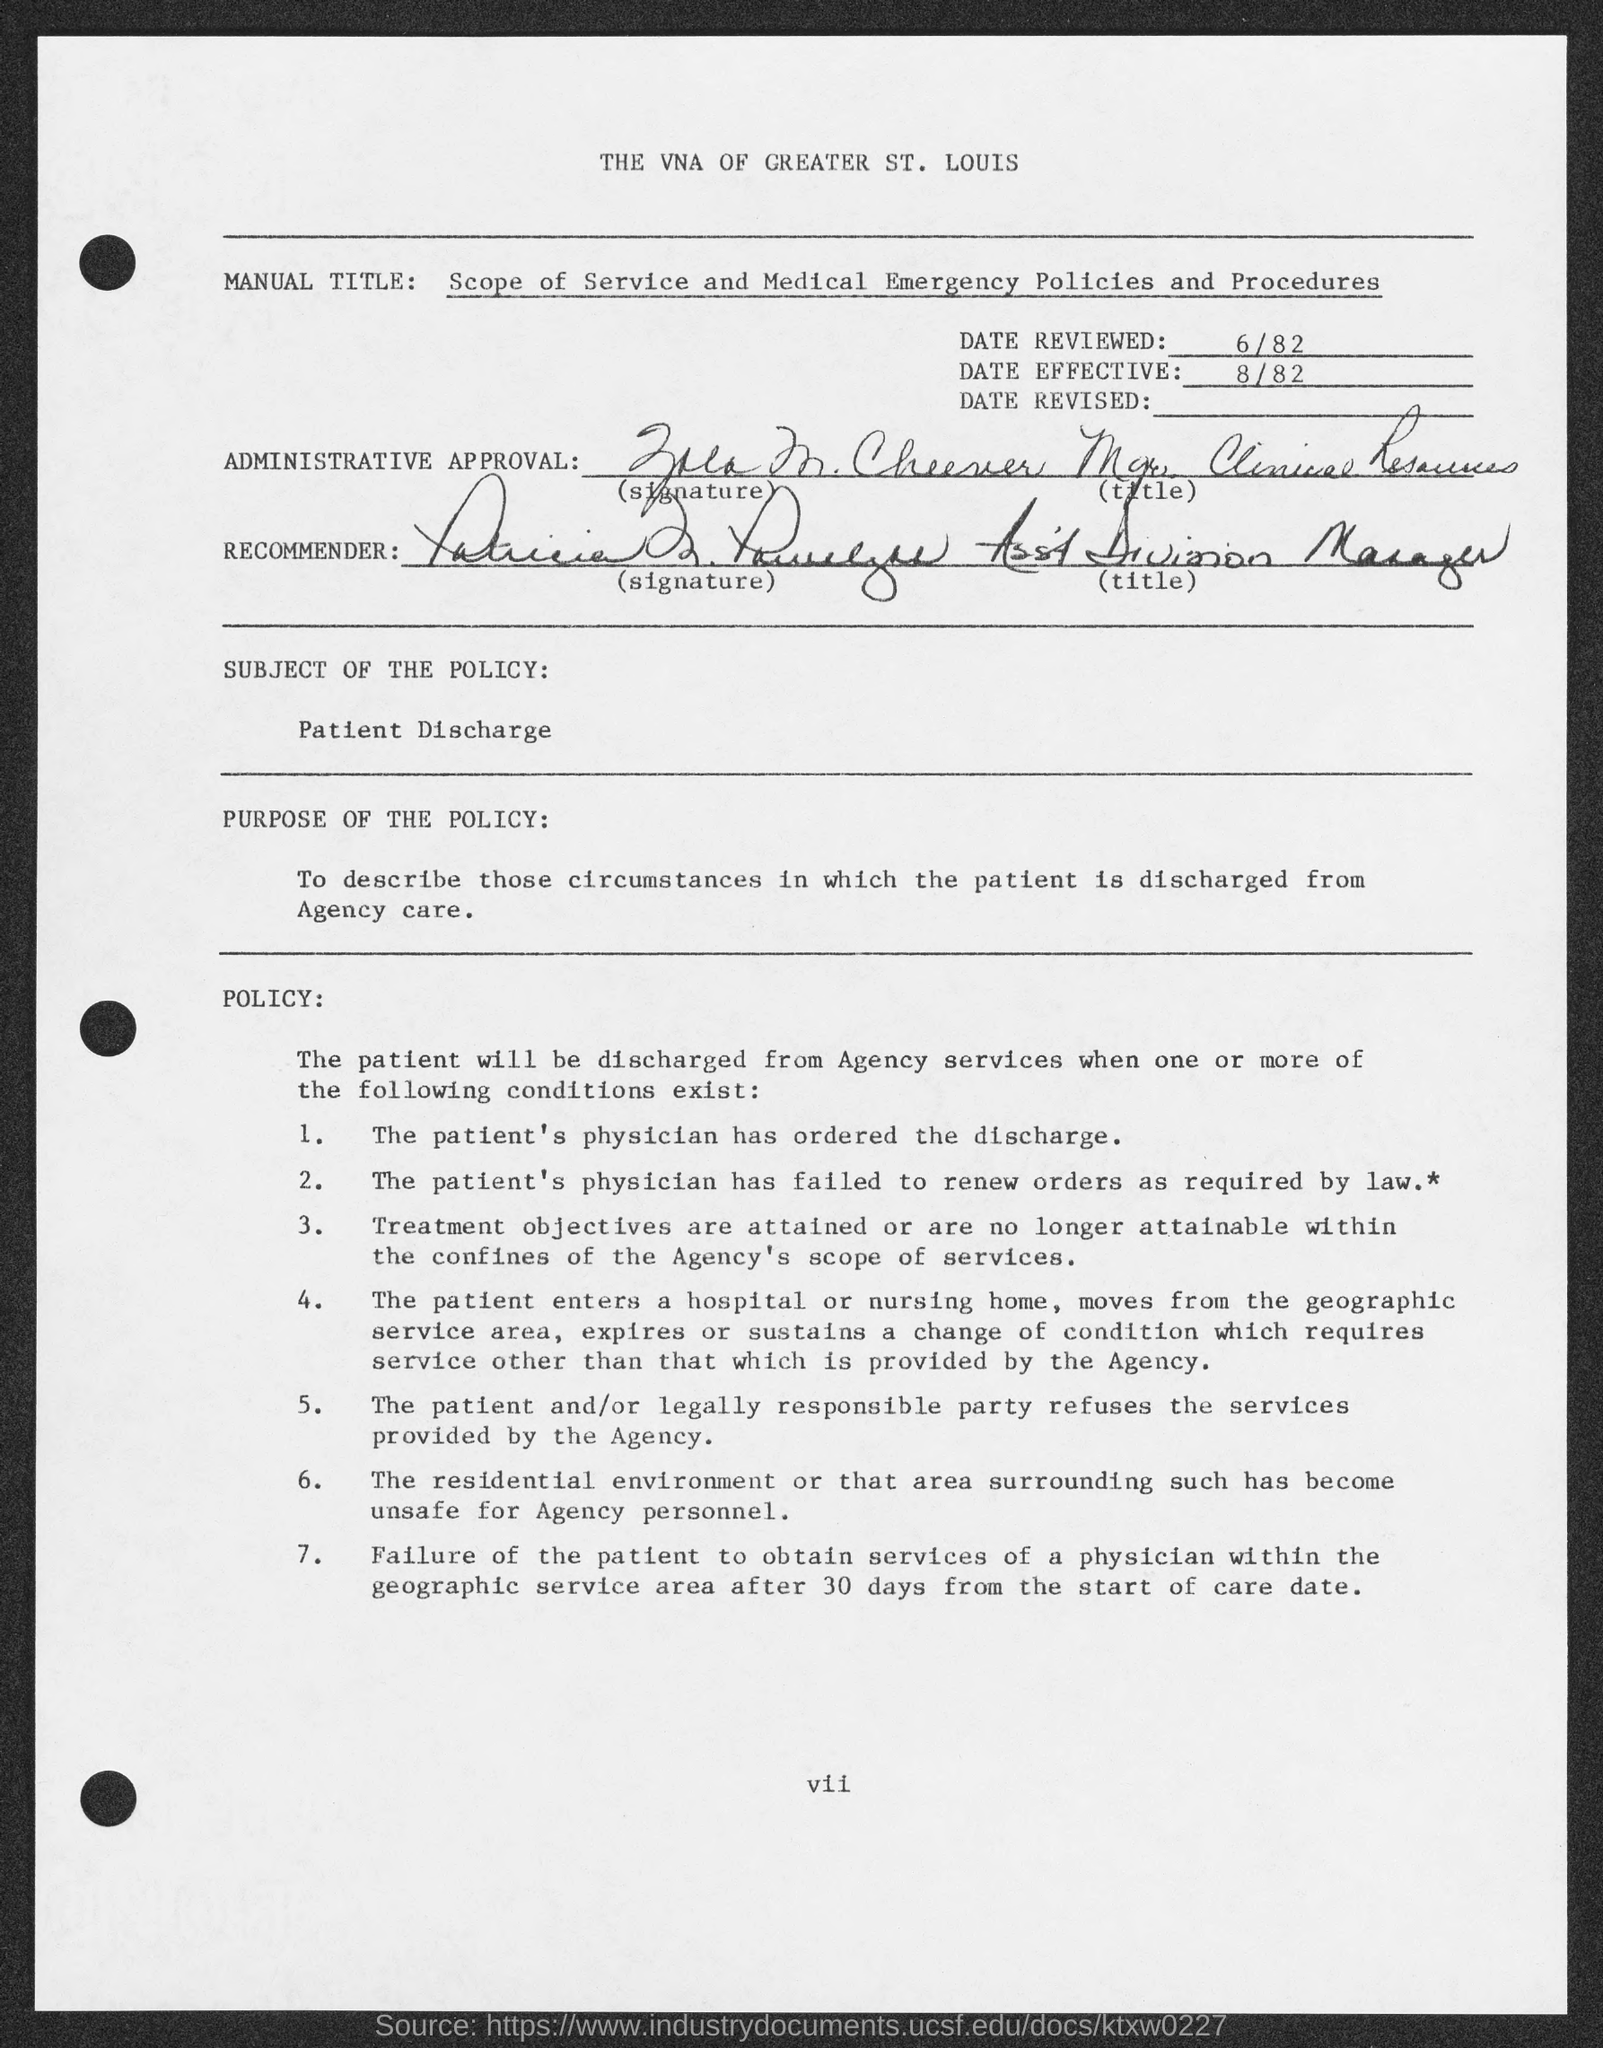Specify some key components in this picture. This document pertains to the manual title 'Scope of Service and Medical Emergency Policies and Procedures'. 